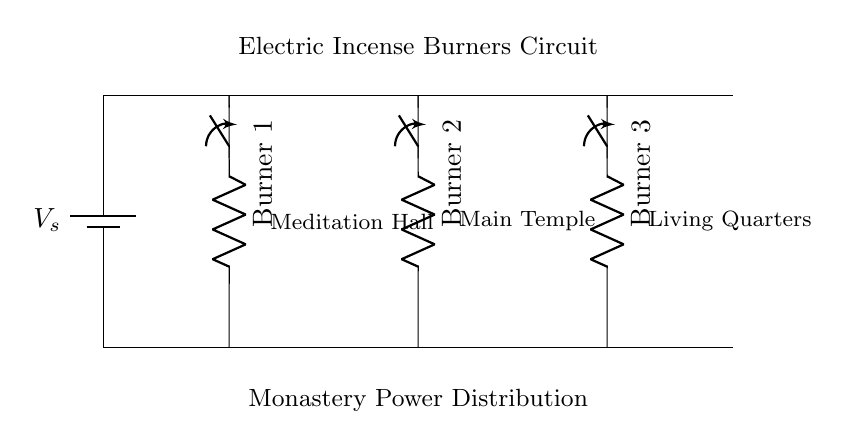What type of circuit is depicted? The circuit is a parallel circuit, as it has multiple branches (each incense burner) that are connected across the same voltage source without affecting each other's operation.
Answer: Parallel How many incense burners are shown? The diagram includes three distinct incense burners, each represented by a resistor.
Answer: Three What voltage source is indicated? The circuit shows a voltage source in the form of a battery labeled as V_s, which supplies power to the entire circuit.
Answer: V_s What area is associated with Burner 1? The label next to Burner 1 indicates that it is located in the Meditation Hall, which is specifically designated for that incense burner in the diagram.
Answer: Meditation Hall If one switch is turned off, what happens to the other burners? Since the burners are part of a parallel configuration, turning off one switch will not affect the operation of the other burners; they will continue to function independently.
Answer: Continue What is the function of the switches in this circuit? The switches allow control over the operation of each incense burner, enabling them to be turned on or off individually without interrupting others.
Answer: Control Which burner is connected to the Living Quarters? Burner 3 is linked to the Living Quarters, as indicated by the label next to this component in the circuit diagram.
Answer: Burner 3 